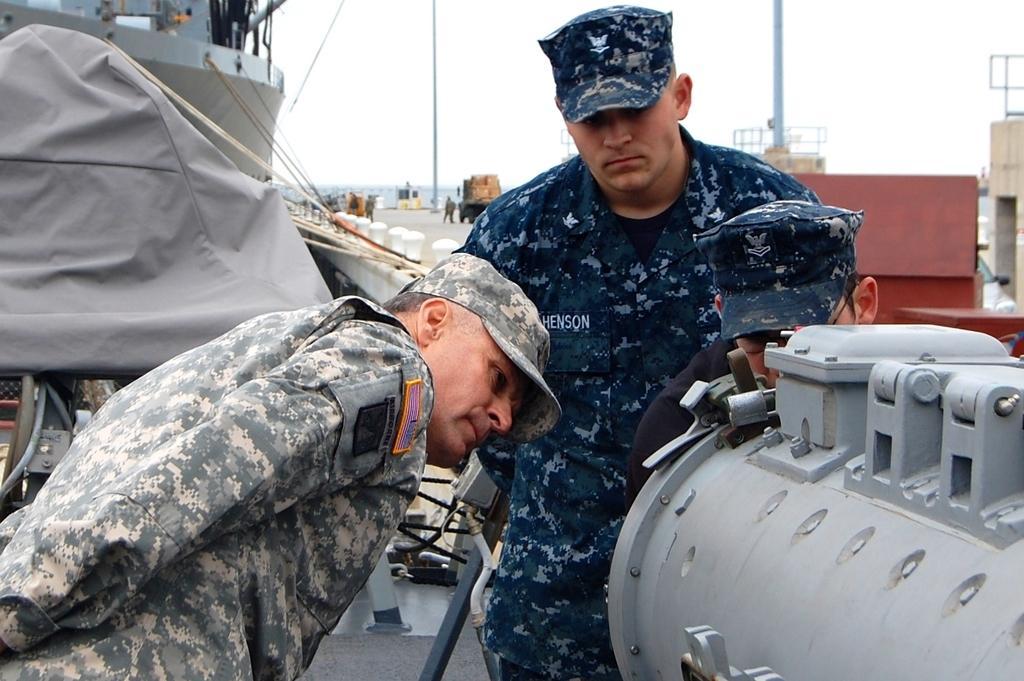Please provide a concise description of this image. In this image we can see some soldiers who are checking something in the ship and at the background of the image there are some persons standing there is vehicle, towers and there is water. 